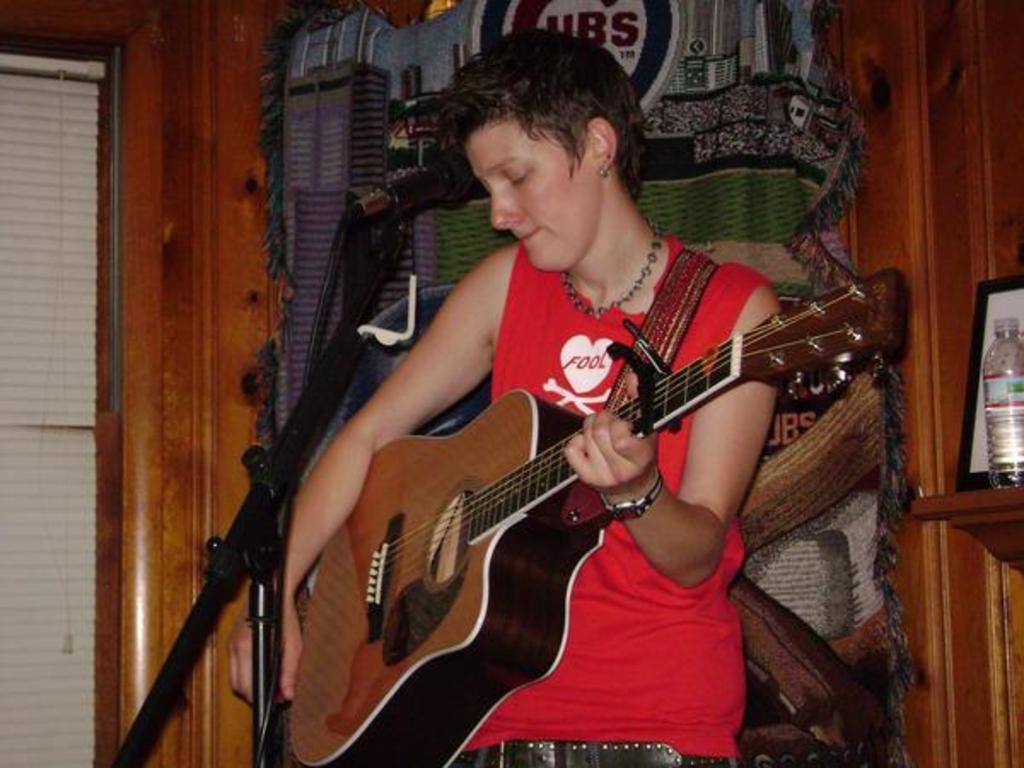Could you give a brief overview of what you see in this image? In this image i can see a person in a red shirt is standing and holding a guitar. I can see a microphone in front of the person. In the background i can see a cloth, a wall , a photo frame ,a bottle and the window blind. 